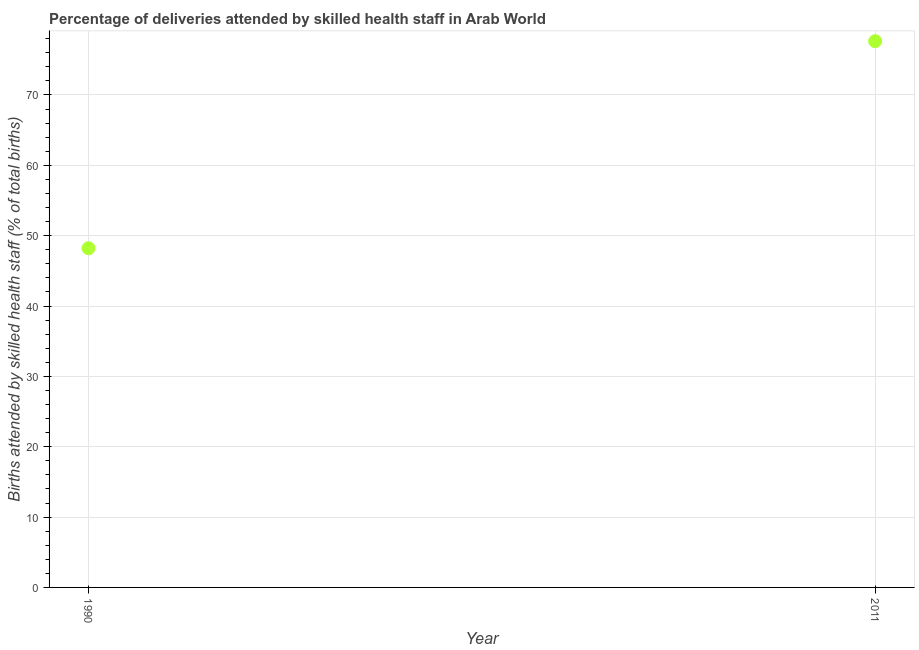What is the number of births attended by skilled health staff in 1990?
Ensure brevity in your answer.  48.22. Across all years, what is the maximum number of births attended by skilled health staff?
Provide a succinct answer. 77.65. Across all years, what is the minimum number of births attended by skilled health staff?
Provide a succinct answer. 48.22. In which year was the number of births attended by skilled health staff maximum?
Keep it short and to the point. 2011. In which year was the number of births attended by skilled health staff minimum?
Offer a terse response. 1990. What is the sum of the number of births attended by skilled health staff?
Your answer should be compact. 125.87. What is the difference between the number of births attended by skilled health staff in 1990 and 2011?
Your answer should be very brief. -29.42. What is the average number of births attended by skilled health staff per year?
Provide a short and direct response. 62.93. What is the median number of births attended by skilled health staff?
Provide a short and direct response. 62.93. Do a majority of the years between 1990 and 2011 (inclusive) have number of births attended by skilled health staff greater than 54 %?
Make the answer very short. No. What is the ratio of the number of births attended by skilled health staff in 1990 to that in 2011?
Offer a terse response. 0.62. Is the number of births attended by skilled health staff in 1990 less than that in 2011?
Keep it short and to the point. Yes. How many dotlines are there?
Give a very brief answer. 1. How many years are there in the graph?
Offer a terse response. 2. Are the values on the major ticks of Y-axis written in scientific E-notation?
Ensure brevity in your answer.  No. Does the graph contain any zero values?
Keep it short and to the point. No. What is the title of the graph?
Your response must be concise. Percentage of deliveries attended by skilled health staff in Arab World. What is the label or title of the X-axis?
Ensure brevity in your answer.  Year. What is the label or title of the Y-axis?
Make the answer very short. Births attended by skilled health staff (% of total births). What is the Births attended by skilled health staff (% of total births) in 1990?
Offer a terse response. 48.22. What is the Births attended by skilled health staff (% of total births) in 2011?
Provide a short and direct response. 77.65. What is the difference between the Births attended by skilled health staff (% of total births) in 1990 and 2011?
Keep it short and to the point. -29.42. What is the ratio of the Births attended by skilled health staff (% of total births) in 1990 to that in 2011?
Offer a terse response. 0.62. 